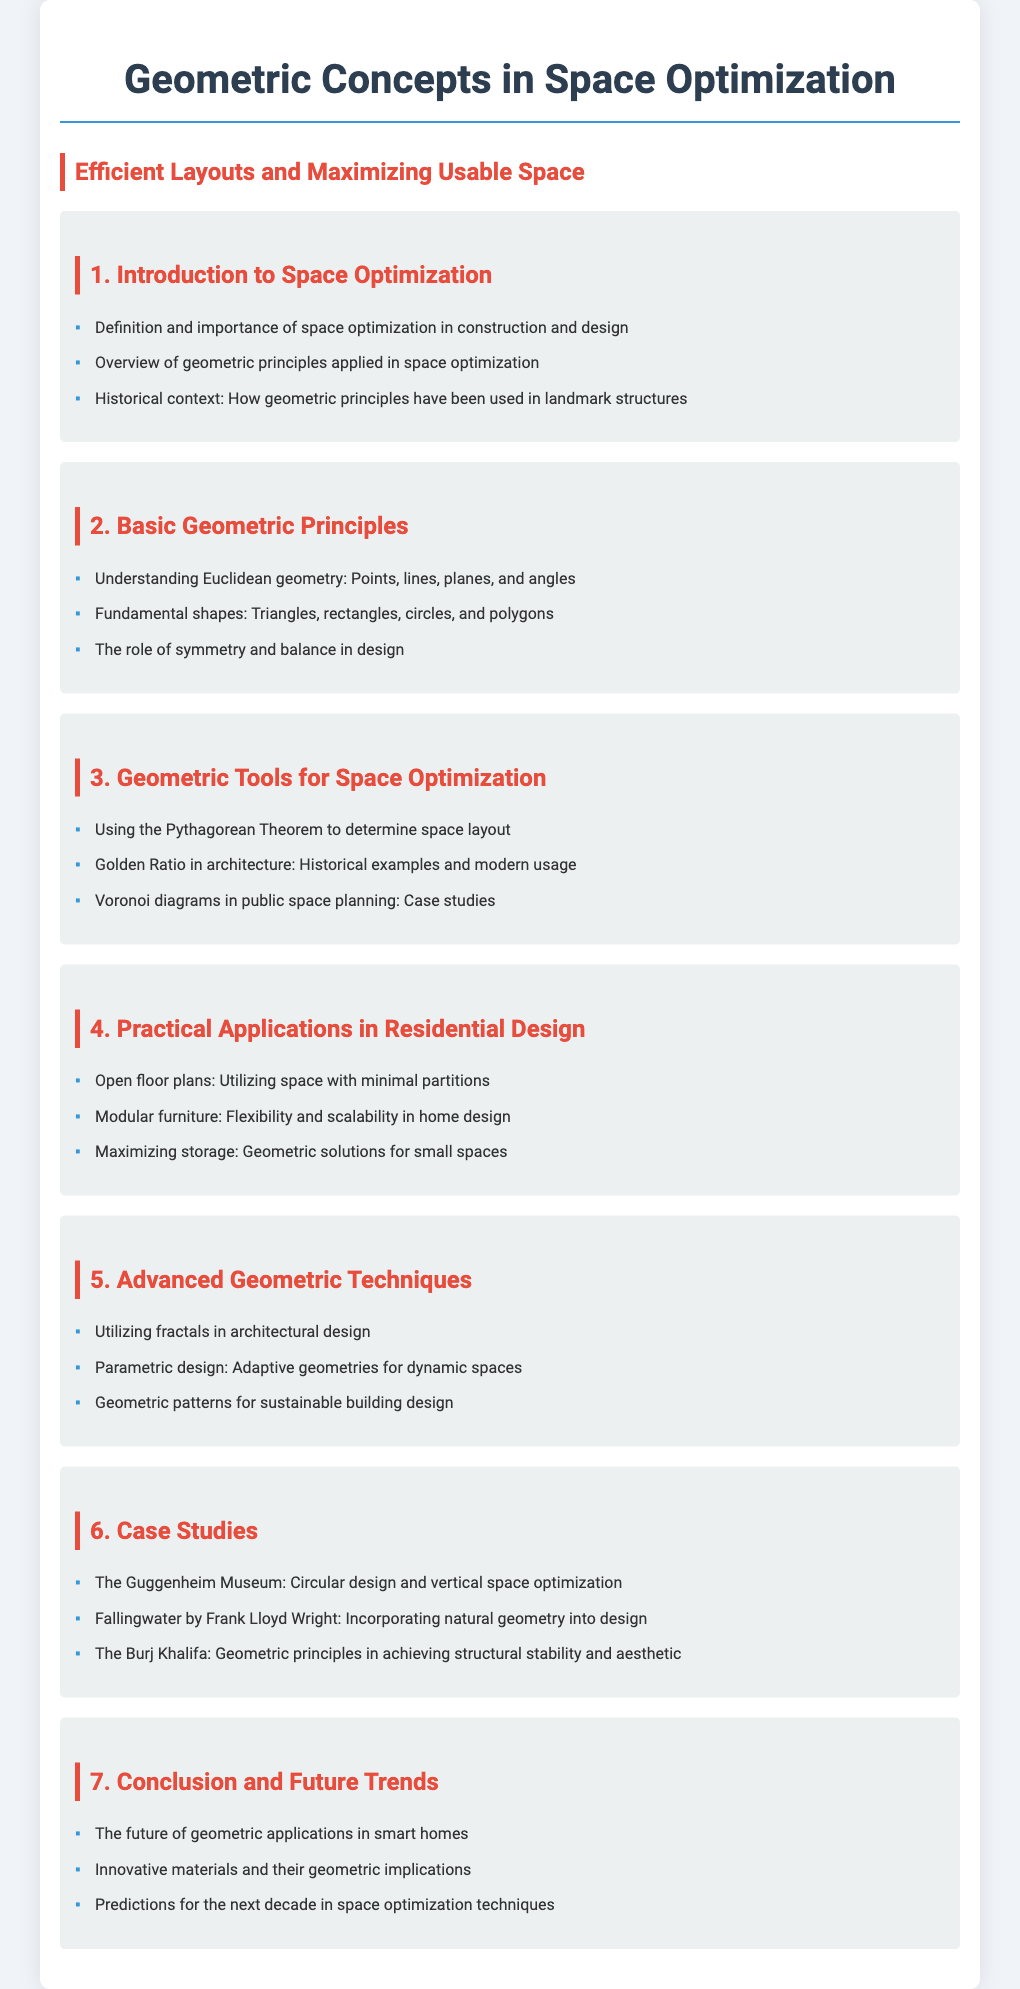What is the first section in the syllabus? The first section is titled "Introduction to Space Optimization."
Answer: Introduction to Space Optimization How many basic geometric principles are covered? There are three fundamental principles listed in the document.
Answer: 3 Which geometric tool is used to determine space layout? The Pythagorean Theorem is mentioned as a tool for determining space layout.
Answer: Pythagorean Theorem What is one application of geometric solutions for small spaces? One application mentioned is maximizing storage.
Answer: Maximizing storage Which case study highlights circular design? The Guggenheim Museum is noted for its circular design.
Answer: The Guggenheim Museum What advanced technique involves adaptive geometries? Parametric design is the technique that involves adaptive geometries.
Answer: Parametric design What is the focus of the conclusion section? The conclusion section discusses future trends in geometric applications.
Answer: Future trends in geometric applications 